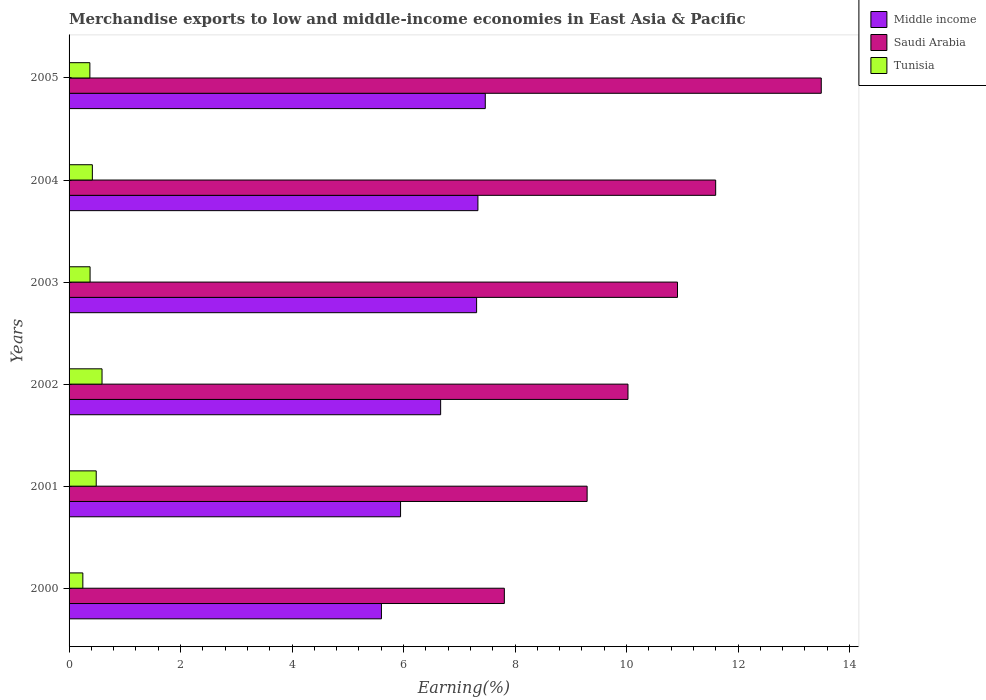How many different coloured bars are there?
Offer a terse response. 3. How many groups of bars are there?
Provide a short and direct response. 6. What is the label of the 2nd group of bars from the top?
Offer a terse response. 2004. In how many cases, is the number of bars for a given year not equal to the number of legend labels?
Ensure brevity in your answer.  0. What is the percentage of amount earned from merchandise exports in Tunisia in 2004?
Keep it short and to the point. 0.42. Across all years, what is the maximum percentage of amount earned from merchandise exports in Saudi Arabia?
Offer a very short reply. 13.49. Across all years, what is the minimum percentage of amount earned from merchandise exports in Middle income?
Your response must be concise. 5.6. What is the total percentage of amount earned from merchandise exports in Tunisia in the graph?
Ensure brevity in your answer.  2.49. What is the difference between the percentage of amount earned from merchandise exports in Saudi Arabia in 2000 and that in 2002?
Offer a terse response. -2.22. What is the difference between the percentage of amount earned from merchandise exports in Saudi Arabia in 2004 and the percentage of amount earned from merchandise exports in Middle income in 2001?
Give a very brief answer. 5.65. What is the average percentage of amount earned from merchandise exports in Middle income per year?
Keep it short and to the point. 6.72. In the year 2000, what is the difference between the percentage of amount earned from merchandise exports in Middle income and percentage of amount earned from merchandise exports in Saudi Arabia?
Your answer should be very brief. -2.2. In how many years, is the percentage of amount earned from merchandise exports in Saudi Arabia greater than 0.4 %?
Ensure brevity in your answer.  6. What is the ratio of the percentage of amount earned from merchandise exports in Middle income in 2001 to that in 2005?
Your response must be concise. 0.8. What is the difference between the highest and the second highest percentage of amount earned from merchandise exports in Tunisia?
Offer a terse response. 0.1. What is the difference between the highest and the lowest percentage of amount earned from merchandise exports in Saudi Arabia?
Offer a very short reply. 5.69. What does the 2nd bar from the top in 2005 represents?
Give a very brief answer. Saudi Arabia. What does the 3rd bar from the bottom in 2004 represents?
Make the answer very short. Tunisia. How many bars are there?
Provide a succinct answer. 18. How many years are there in the graph?
Provide a short and direct response. 6. Are the values on the major ticks of X-axis written in scientific E-notation?
Your answer should be very brief. No. Does the graph contain grids?
Ensure brevity in your answer.  No. Where does the legend appear in the graph?
Offer a very short reply. Top right. What is the title of the graph?
Provide a short and direct response. Merchandise exports to low and middle-income economies in East Asia & Pacific. What is the label or title of the X-axis?
Your response must be concise. Earning(%). What is the Earning(%) of Middle income in 2000?
Keep it short and to the point. 5.6. What is the Earning(%) in Saudi Arabia in 2000?
Your response must be concise. 7.81. What is the Earning(%) in Tunisia in 2000?
Make the answer very short. 0.25. What is the Earning(%) in Middle income in 2001?
Your answer should be very brief. 5.95. What is the Earning(%) in Saudi Arabia in 2001?
Your response must be concise. 9.29. What is the Earning(%) of Tunisia in 2001?
Your answer should be very brief. 0.49. What is the Earning(%) in Middle income in 2002?
Ensure brevity in your answer.  6.67. What is the Earning(%) of Saudi Arabia in 2002?
Provide a short and direct response. 10.03. What is the Earning(%) of Tunisia in 2002?
Offer a terse response. 0.59. What is the Earning(%) of Middle income in 2003?
Your response must be concise. 7.31. What is the Earning(%) in Saudi Arabia in 2003?
Provide a succinct answer. 10.91. What is the Earning(%) in Tunisia in 2003?
Offer a terse response. 0.38. What is the Earning(%) of Middle income in 2004?
Your response must be concise. 7.33. What is the Earning(%) of Saudi Arabia in 2004?
Provide a succinct answer. 11.6. What is the Earning(%) in Tunisia in 2004?
Provide a short and direct response. 0.42. What is the Earning(%) in Middle income in 2005?
Offer a terse response. 7.47. What is the Earning(%) in Saudi Arabia in 2005?
Provide a succinct answer. 13.49. What is the Earning(%) of Tunisia in 2005?
Ensure brevity in your answer.  0.37. Across all years, what is the maximum Earning(%) in Middle income?
Provide a succinct answer. 7.47. Across all years, what is the maximum Earning(%) of Saudi Arabia?
Give a very brief answer. 13.49. Across all years, what is the maximum Earning(%) of Tunisia?
Ensure brevity in your answer.  0.59. Across all years, what is the minimum Earning(%) of Middle income?
Your answer should be very brief. 5.6. Across all years, what is the minimum Earning(%) of Saudi Arabia?
Offer a very short reply. 7.81. Across all years, what is the minimum Earning(%) in Tunisia?
Your answer should be compact. 0.25. What is the total Earning(%) in Middle income in the graph?
Give a very brief answer. 40.33. What is the total Earning(%) of Saudi Arabia in the graph?
Your response must be concise. 63.13. What is the total Earning(%) in Tunisia in the graph?
Provide a succinct answer. 2.49. What is the difference between the Earning(%) in Middle income in 2000 and that in 2001?
Ensure brevity in your answer.  -0.34. What is the difference between the Earning(%) of Saudi Arabia in 2000 and that in 2001?
Provide a short and direct response. -1.49. What is the difference between the Earning(%) of Tunisia in 2000 and that in 2001?
Give a very brief answer. -0.24. What is the difference between the Earning(%) in Middle income in 2000 and that in 2002?
Your response must be concise. -1.06. What is the difference between the Earning(%) of Saudi Arabia in 2000 and that in 2002?
Offer a terse response. -2.22. What is the difference between the Earning(%) in Tunisia in 2000 and that in 2002?
Make the answer very short. -0.34. What is the difference between the Earning(%) in Middle income in 2000 and that in 2003?
Make the answer very short. -1.71. What is the difference between the Earning(%) in Saudi Arabia in 2000 and that in 2003?
Your response must be concise. -3.11. What is the difference between the Earning(%) of Tunisia in 2000 and that in 2003?
Provide a short and direct response. -0.13. What is the difference between the Earning(%) in Middle income in 2000 and that in 2004?
Provide a short and direct response. -1.73. What is the difference between the Earning(%) in Saudi Arabia in 2000 and that in 2004?
Offer a terse response. -3.79. What is the difference between the Earning(%) of Tunisia in 2000 and that in 2004?
Offer a very short reply. -0.17. What is the difference between the Earning(%) of Middle income in 2000 and that in 2005?
Your answer should be compact. -1.86. What is the difference between the Earning(%) of Saudi Arabia in 2000 and that in 2005?
Make the answer very short. -5.69. What is the difference between the Earning(%) in Tunisia in 2000 and that in 2005?
Ensure brevity in your answer.  -0.13. What is the difference between the Earning(%) in Middle income in 2001 and that in 2002?
Provide a short and direct response. -0.72. What is the difference between the Earning(%) of Saudi Arabia in 2001 and that in 2002?
Your response must be concise. -0.73. What is the difference between the Earning(%) in Tunisia in 2001 and that in 2002?
Your answer should be very brief. -0.1. What is the difference between the Earning(%) of Middle income in 2001 and that in 2003?
Ensure brevity in your answer.  -1.36. What is the difference between the Earning(%) of Saudi Arabia in 2001 and that in 2003?
Make the answer very short. -1.62. What is the difference between the Earning(%) in Tunisia in 2001 and that in 2003?
Provide a succinct answer. 0.11. What is the difference between the Earning(%) of Middle income in 2001 and that in 2004?
Keep it short and to the point. -1.39. What is the difference between the Earning(%) of Saudi Arabia in 2001 and that in 2004?
Your answer should be very brief. -2.31. What is the difference between the Earning(%) of Tunisia in 2001 and that in 2004?
Provide a short and direct response. 0.07. What is the difference between the Earning(%) of Middle income in 2001 and that in 2005?
Offer a terse response. -1.52. What is the difference between the Earning(%) in Saudi Arabia in 2001 and that in 2005?
Keep it short and to the point. -4.2. What is the difference between the Earning(%) in Tunisia in 2001 and that in 2005?
Offer a very short reply. 0.11. What is the difference between the Earning(%) of Middle income in 2002 and that in 2003?
Ensure brevity in your answer.  -0.65. What is the difference between the Earning(%) of Saudi Arabia in 2002 and that in 2003?
Provide a succinct answer. -0.89. What is the difference between the Earning(%) of Tunisia in 2002 and that in 2003?
Your answer should be compact. 0.21. What is the difference between the Earning(%) of Middle income in 2002 and that in 2004?
Your answer should be compact. -0.67. What is the difference between the Earning(%) in Saudi Arabia in 2002 and that in 2004?
Offer a very short reply. -1.57. What is the difference between the Earning(%) of Tunisia in 2002 and that in 2004?
Your answer should be compact. 0.17. What is the difference between the Earning(%) of Middle income in 2002 and that in 2005?
Give a very brief answer. -0.8. What is the difference between the Earning(%) in Saudi Arabia in 2002 and that in 2005?
Provide a short and direct response. -3.47. What is the difference between the Earning(%) of Tunisia in 2002 and that in 2005?
Provide a short and direct response. 0.22. What is the difference between the Earning(%) in Middle income in 2003 and that in 2004?
Offer a terse response. -0.02. What is the difference between the Earning(%) in Saudi Arabia in 2003 and that in 2004?
Ensure brevity in your answer.  -0.69. What is the difference between the Earning(%) in Tunisia in 2003 and that in 2004?
Your answer should be very brief. -0.04. What is the difference between the Earning(%) of Middle income in 2003 and that in 2005?
Provide a succinct answer. -0.16. What is the difference between the Earning(%) of Saudi Arabia in 2003 and that in 2005?
Provide a short and direct response. -2.58. What is the difference between the Earning(%) of Tunisia in 2003 and that in 2005?
Offer a very short reply. 0. What is the difference between the Earning(%) of Middle income in 2004 and that in 2005?
Offer a very short reply. -0.13. What is the difference between the Earning(%) of Saudi Arabia in 2004 and that in 2005?
Give a very brief answer. -1.89. What is the difference between the Earning(%) of Tunisia in 2004 and that in 2005?
Your answer should be very brief. 0.04. What is the difference between the Earning(%) of Middle income in 2000 and the Earning(%) of Saudi Arabia in 2001?
Your answer should be very brief. -3.69. What is the difference between the Earning(%) in Middle income in 2000 and the Earning(%) in Tunisia in 2001?
Offer a terse response. 5.12. What is the difference between the Earning(%) in Saudi Arabia in 2000 and the Earning(%) in Tunisia in 2001?
Make the answer very short. 7.32. What is the difference between the Earning(%) of Middle income in 2000 and the Earning(%) of Saudi Arabia in 2002?
Provide a short and direct response. -4.42. What is the difference between the Earning(%) of Middle income in 2000 and the Earning(%) of Tunisia in 2002?
Your answer should be very brief. 5.01. What is the difference between the Earning(%) in Saudi Arabia in 2000 and the Earning(%) in Tunisia in 2002?
Your answer should be compact. 7.22. What is the difference between the Earning(%) of Middle income in 2000 and the Earning(%) of Saudi Arabia in 2003?
Keep it short and to the point. -5.31. What is the difference between the Earning(%) of Middle income in 2000 and the Earning(%) of Tunisia in 2003?
Offer a very short reply. 5.23. What is the difference between the Earning(%) of Saudi Arabia in 2000 and the Earning(%) of Tunisia in 2003?
Ensure brevity in your answer.  7.43. What is the difference between the Earning(%) in Middle income in 2000 and the Earning(%) in Saudi Arabia in 2004?
Offer a very short reply. -6. What is the difference between the Earning(%) in Middle income in 2000 and the Earning(%) in Tunisia in 2004?
Your response must be concise. 5.19. What is the difference between the Earning(%) in Saudi Arabia in 2000 and the Earning(%) in Tunisia in 2004?
Offer a terse response. 7.39. What is the difference between the Earning(%) of Middle income in 2000 and the Earning(%) of Saudi Arabia in 2005?
Give a very brief answer. -7.89. What is the difference between the Earning(%) of Middle income in 2000 and the Earning(%) of Tunisia in 2005?
Make the answer very short. 5.23. What is the difference between the Earning(%) in Saudi Arabia in 2000 and the Earning(%) in Tunisia in 2005?
Your answer should be compact. 7.43. What is the difference between the Earning(%) of Middle income in 2001 and the Earning(%) of Saudi Arabia in 2002?
Keep it short and to the point. -4.08. What is the difference between the Earning(%) in Middle income in 2001 and the Earning(%) in Tunisia in 2002?
Provide a short and direct response. 5.36. What is the difference between the Earning(%) of Saudi Arabia in 2001 and the Earning(%) of Tunisia in 2002?
Your answer should be very brief. 8.7. What is the difference between the Earning(%) in Middle income in 2001 and the Earning(%) in Saudi Arabia in 2003?
Provide a succinct answer. -4.97. What is the difference between the Earning(%) of Middle income in 2001 and the Earning(%) of Tunisia in 2003?
Your response must be concise. 5.57. What is the difference between the Earning(%) of Saudi Arabia in 2001 and the Earning(%) of Tunisia in 2003?
Keep it short and to the point. 8.92. What is the difference between the Earning(%) of Middle income in 2001 and the Earning(%) of Saudi Arabia in 2004?
Your answer should be compact. -5.65. What is the difference between the Earning(%) in Middle income in 2001 and the Earning(%) in Tunisia in 2004?
Provide a succinct answer. 5.53. What is the difference between the Earning(%) of Saudi Arabia in 2001 and the Earning(%) of Tunisia in 2004?
Your response must be concise. 8.88. What is the difference between the Earning(%) in Middle income in 2001 and the Earning(%) in Saudi Arabia in 2005?
Offer a very short reply. -7.55. What is the difference between the Earning(%) of Middle income in 2001 and the Earning(%) of Tunisia in 2005?
Ensure brevity in your answer.  5.57. What is the difference between the Earning(%) in Saudi Arabia in 2001 and the Earning(%) in Tunisia in 2005?
Provide a succinct answer. 8.92. What is the difference between the Earning(%) in Middle income in 2002 and the Earning(%) in Saudi Arabia in 2003?
Provide a short and direct response. -4.25. What is the difference between the Earning(%) of Middle income in 2002 and the Earning(%) of Tunisia in 2003?
Ensure brevity in your answer.  6.29. What is the difference between the Earning(%) in Saudi Arabia in 2002 and the Earning(%) in Tunisia in 2003?
Your response must be concise. 9.65. What is the difference between the Earning(%) in Middle income in 2002 and the Earning(%) in Saudi Arabia in 2004?
Your response must be concise. -4.93. What is the difference between the Earning(%) in Middle income in 2002 and the Earning(%) in Tunisia in 2004?
Provide a succinct answer. 6.25. What is the difference between the Earning(%) of Saudi Arabia in 2002 and the Earning(%) of Tunisia in 2004?
Provide a short and direct response. 9.61. What is the difference between the Earning(%) of Middle income in 2002 and the Earning(%) of Saudi Arabia in 2005?
Offer a terse response. -6.83. What is the difference between the Earning(%) in Middle income in 2002 and the Earning(%) in Tunisia in 2005?
Offer a very short reply. 6.29. What is the difference between the Earning(%) in Saudi Arabia in 2002 and the Earning(%) in Tunisia in 2005?
Make the answer very short. 9.65. What is the difference between the Earning(%) in Middle income in 2003 and the Earning(%) in Saudi Arabia in 2004?
Your response must be concise. -4.29. What is the difference between the Earning(%) of Middle income in 2003 and the Earning(%) of Tunisia in 2004?
Keep it short and to the point. 6.89. What is the difference between the Earning(%) in Saudi Arabia in 2003 and the Earning(%) in Tunisia in 2004?
Offer a terse response. 10.5. What is the difference between the Earning(%) in Middle income in 2003 and the Earning(%) in Saudi Arabia in 2005?
Offer a terse response. -6.18. What is the difference between the Earning(%) in Middle income in 2003 and the Earning(%) in Tunisia in 2005?
Provide a short and direct response. 6.94. What is the difference between the Earning(%) in Saudi Arabia in 2003 and the Earning(%) in Tunisia in 2005?
Provide a short and direct response. 10.54. What is the difference between the Earning(%) in Middle income in 2004 and the Earning(%) in Saudi Arabia in 2005?
Make the answer very short. -6.16. What is the difference between the Earning(%) in Middle income in 2004 and the Earning(%) in Tunisia in 2005?
Offer a very short reply. 6.96. What is the difference between the Earning(%) of Saudi Arabia in 2004 and the Earning(%) of Tunisia in 2005?
Offer a very short reply. 11.23. What is the average Earning(%) of Middle income per year?
Offer a very short reply. 6.72. What is the average Earning(%) in Saudi Arabia per year?
Keep it short and to the point. 10.52. What is the average Earning(%) in Tunisia per year?
Provide a short and direct response. 0.42. In the year 2000, what is the difference between the Earning(%) in Middle income and Earning(%) in Saudi Arabia?
Provide a short and direct response. -2.2. In the year 2000, what is the difference between the Earning(%) of Middle income and Earning(%) of Tunisia?
Offer a terse response. 5.36. In the year 2000, what is the difference between the Earning(%) of Saudi Arabia and Earning(%) of Tunisia?
Your response must be concise. 7.56. In the year 2001, what is the difference between the Earning(%) of Middle income and Earning(%) of Saudi Arabia?
Give a very brief answer. -3.35. In the year 2001, what is the difference between the Earning(%) of Middle income and Earning(%) of Tunisia?
Your answer should be very brief. 5.46. In the year 2001, what is the difference between the Earning(%) of Saudi Arabia and Earning(%) of Tunisia?
Provide a succinct answer. 8.81. In the year 2002, what is the difference between the Earning(%) in Middle income and Earning(%) in Saudi Arabia?
Offer a very short reply. -3.36. In the year 2002, what is the difference between the Earning(%) in Middle income and Earning(%) in Tunisia?
Your answer should be compact. 6.07. In the year 2002, what is the difference between the Earning(%) of Saudi Arabia and Earning(%) of Tunisia?
Offer a terse response. 9.43. In the year 2003, what is the difference between the Earning(%) of Middle income and Earning(%) of Saudi Arabia?
Your answer should be compact. -3.6. In the year 2003, what is the difference between the Earning(%) in Middle income and Earning(%) in Tunisia?
Offer a very short reply. 6.93. In the year 2003, what is the difference between the Earning(%) of Saudi Arabia and Earning(%) of Tunisia?
Make the answer very short. 10.54. In the year 2004, what is the difference between the Earning(%) in Middle income and Earning(%) in Saudi Arabia?
Offer a terse response. -4.27. In the year 2004, what is the difference between the Earning(%) of Middle income and Earning(%) of Tunisia?
Your answer should be very brief. 6.92. In the year 2004, what is the difference between the Earning(%) in Saudi Arabia and Earning(%) in Tunisia?
Your answer should be compact. 11.18. In the year 2005, what is the difference between the Earning(%) of Middle income and Earning(%) of Saudi Arabia?
Provide a short and direct response. -6.03. In the year 2005, what is the difference between the Earning(%) in Middle income and Earning(%) in Tunisia?
Provide a short and direct response. 7.09. In the year 2005, what is the difference between the Earning(%) in Saudi Arabia and Earning(%) in Tunisia?
Provide a succinct answer. 13.12. What is the ratio of the Earning(%) of Middle income in 2000 to that in 2001?
Your answer should be compact. 0.94. What is the ratio of the Earning(%) in Saudi Arabia in 2000 to that in 2001?
Offer a terse response. 0.84. What is the ratio of the Earning(%) of Tunisia in 2000 to that in 2001?
Your answer should be very brief. 0.51. What is the ratio of the Earning(%) of Middle income in 2000 to that in 2002?
Provide a short and direct response. 0.84. What is the ratio of the Earning(%) of Saudi Arabia in 2000 to that in 2002?
Offer a very short reply. 0.78. What is the ratio of the Earning(%) in Tunisia in 2000 to that in 2002?
Keep it short and to the point. 0.42. What is the ratio of the Earning(%) in Middle income in 2000 to that in 2003?
Your answer should be compact. 0.77. What is the ratio of the Earning(%) of Saudi Arabia in 2000 to that in 2003?
Keep it short and to the point. 0.72. What is the ratio of the Earning(%) of Tunisia in 2000 to that in 2003?
Your response must be concise. 0.66. What is the ratio of the Earning(%) of Middle income in 2000 to that in 2004?
Make the answer very short. 0.76. What is the ratio of the Earning(%) in Saudi Arabia in 2000 to that in 2004?
Your answer should be compact. 0.67. What is the ratio of the Earning(%) of Tunisia in 2000 to that in 2004?
Your answer should be very brief. 0.59. What is the ratio of the Earning(%) of Middle income in 2000 to that in 2005?
Keep it short and to the point. 0.75. What is the ratio of the Earning(%) of Saudi Arabia in 2000 to that in 2005?
Keep it short and to the point. 0.58. What is the ratio of the Earning(%) in Tunisia in 2000 to that in 2005?
Your answer should be compact. 0.66. What is the ratio of the Earning(%) of Middle income in 2001 to that in 2002?
Offer a very short reply. 0.89. What is the ratio of the Earning(%) of Saudi Arabia in 2001 to that in 2002?
Offer a terse response. 0.93. What is the ratio of the Earning(%) in Tunisia in 2001 to that in 2002?
Provide a succinct answer. 0.82. What is the ratio of the Earning(%) of Middle income in 2001 to that in 2003?
Offer a terse response. 0.81. What is the ratio of the Earning(%) of Saudi Arabia in 2001 to that in 2003?
Your answer should be compact. 0.85. What is the ratio of the Earning(%) in Tunisia in 2001 to that in 2003?
Ensure brevity in your answer.  1.29. What is the ratio of the Earning(%) in Middle income in 2001 to that in 2004?
Your response must be concise. 0.81. What is the ratio of the Earning(%) in Saudi Arabia in 2001 to that in 2004?
Offer a terse response. 0.8. What is the ratio of the Earning(%) of Tunisia in 2001 to that in 2004?
Make the answer very short. 1.17. What is the ratio of the Earning(%) in Middle income in 2001 to that in 2005?
Give a very brief answer. 0.8. What is the ratio of the Earning(%) of Saudi Arabia in 2001 to that in 2005?
Make the answer very short. 0.69. What is the ratio of the Earning(%) of Tunisia in 2001 to that in 2005?
Make the answer very short. 1.31. What is the ratio of the Earning(%) of Middle income in 2002 to that in 2003?
Make the answer very short. 0.91. What is the ratio of the Earning(%) in Saudi Arabia in 2002 to that in 2003?
Provide a short and direct response. 0.92. What is the ratio of the Earning(%) of Tunisia in 2002 to that in 2003?
Your answer should be very brief. 1.57. What is the ratio of the Earning(%) in Middle income in 2002 to that in 2004?
Your response must be concise. 0.91. What is the ratio of the Earning(%) in Saudi Arabia in 2002 to that in 2004?
Make the answer very short. 0.86. What is the ratio of the Earning(%) of Tunisia in 2002 to that in 2004?
Your answer should be compact. 1.42. What is the ratio of the Earning(%) in Middle income in 2002 to that in 2005?
Your response must be concise. 0.89. What is the ratio of the Earning(%) in Saudi Arabia in 2002 to that in 2005?
Your response must be concise. 0.74. What is the ratio of the Earning(%) in Tunisia in 2002 to that in 2005?
Ensure brevity in your answer.  1.58. What is the ratio of the Earning(%) in Middle income in 2003 to that in 2004?
Keep it short and to the point. 1. What is the ratio of the Earning(%) in Saudi Arabia in 2003 to that in 2004?
Your answer should be very brief. 0.94. What is the ratio of the Earning(%) in Tunisia in 2003 to that in 2004?
Ensure brevity in your answer.  0.9. What is the ratio of the Earning(%) in Middle income in 2003 to that in 2005?
Give a very brief answer. 0.98. What is the ratio of the Earning(%) of Saudi Arabia in 2003 to that in 2005?
Your answer should be very brief. 0.81. What is the ratio of the Earning(%) in Tunisia in 2003 to that in 2005?
Your answer should be very brief. 1.01. What is the ratio of the Earning(%) in Middle income in 2004 to that in 2005?
Provide a succinct answer. 0.98. What is the ratio of the Earning(%) in Saudi Arabia in 2004 to that in 2005?
Ensure brevity in your answer.  0.86. What is the ratio of the Earning(%) in Tunisia in 2004 to that in 2005?
Your answer should be compact. 1.12. What is the difference between the highest and the second highest Earning(%) in Middle income?
Give a very brief answer. 0.13. What is the difference between the highest and the second highest Earning(%) in Saudi Arabia?
Give a very brief answer. 1.89. What is the difference between the highest and the second highest Earning(%) of Tunisia?
Provide a succinct answer. 0.1. What is the difference between the highest and the lowest Earning(%) of Middle income?
Your response must be concise. 1.86. What is the difference between the highest and the lowest Earning(%) of Saudi Arabia?
Your response must be concise. 5.69. What is the difference between the highest and the lowest Earning(%) in Tunisia?
Ensure brevity in your answer.  0.34. 